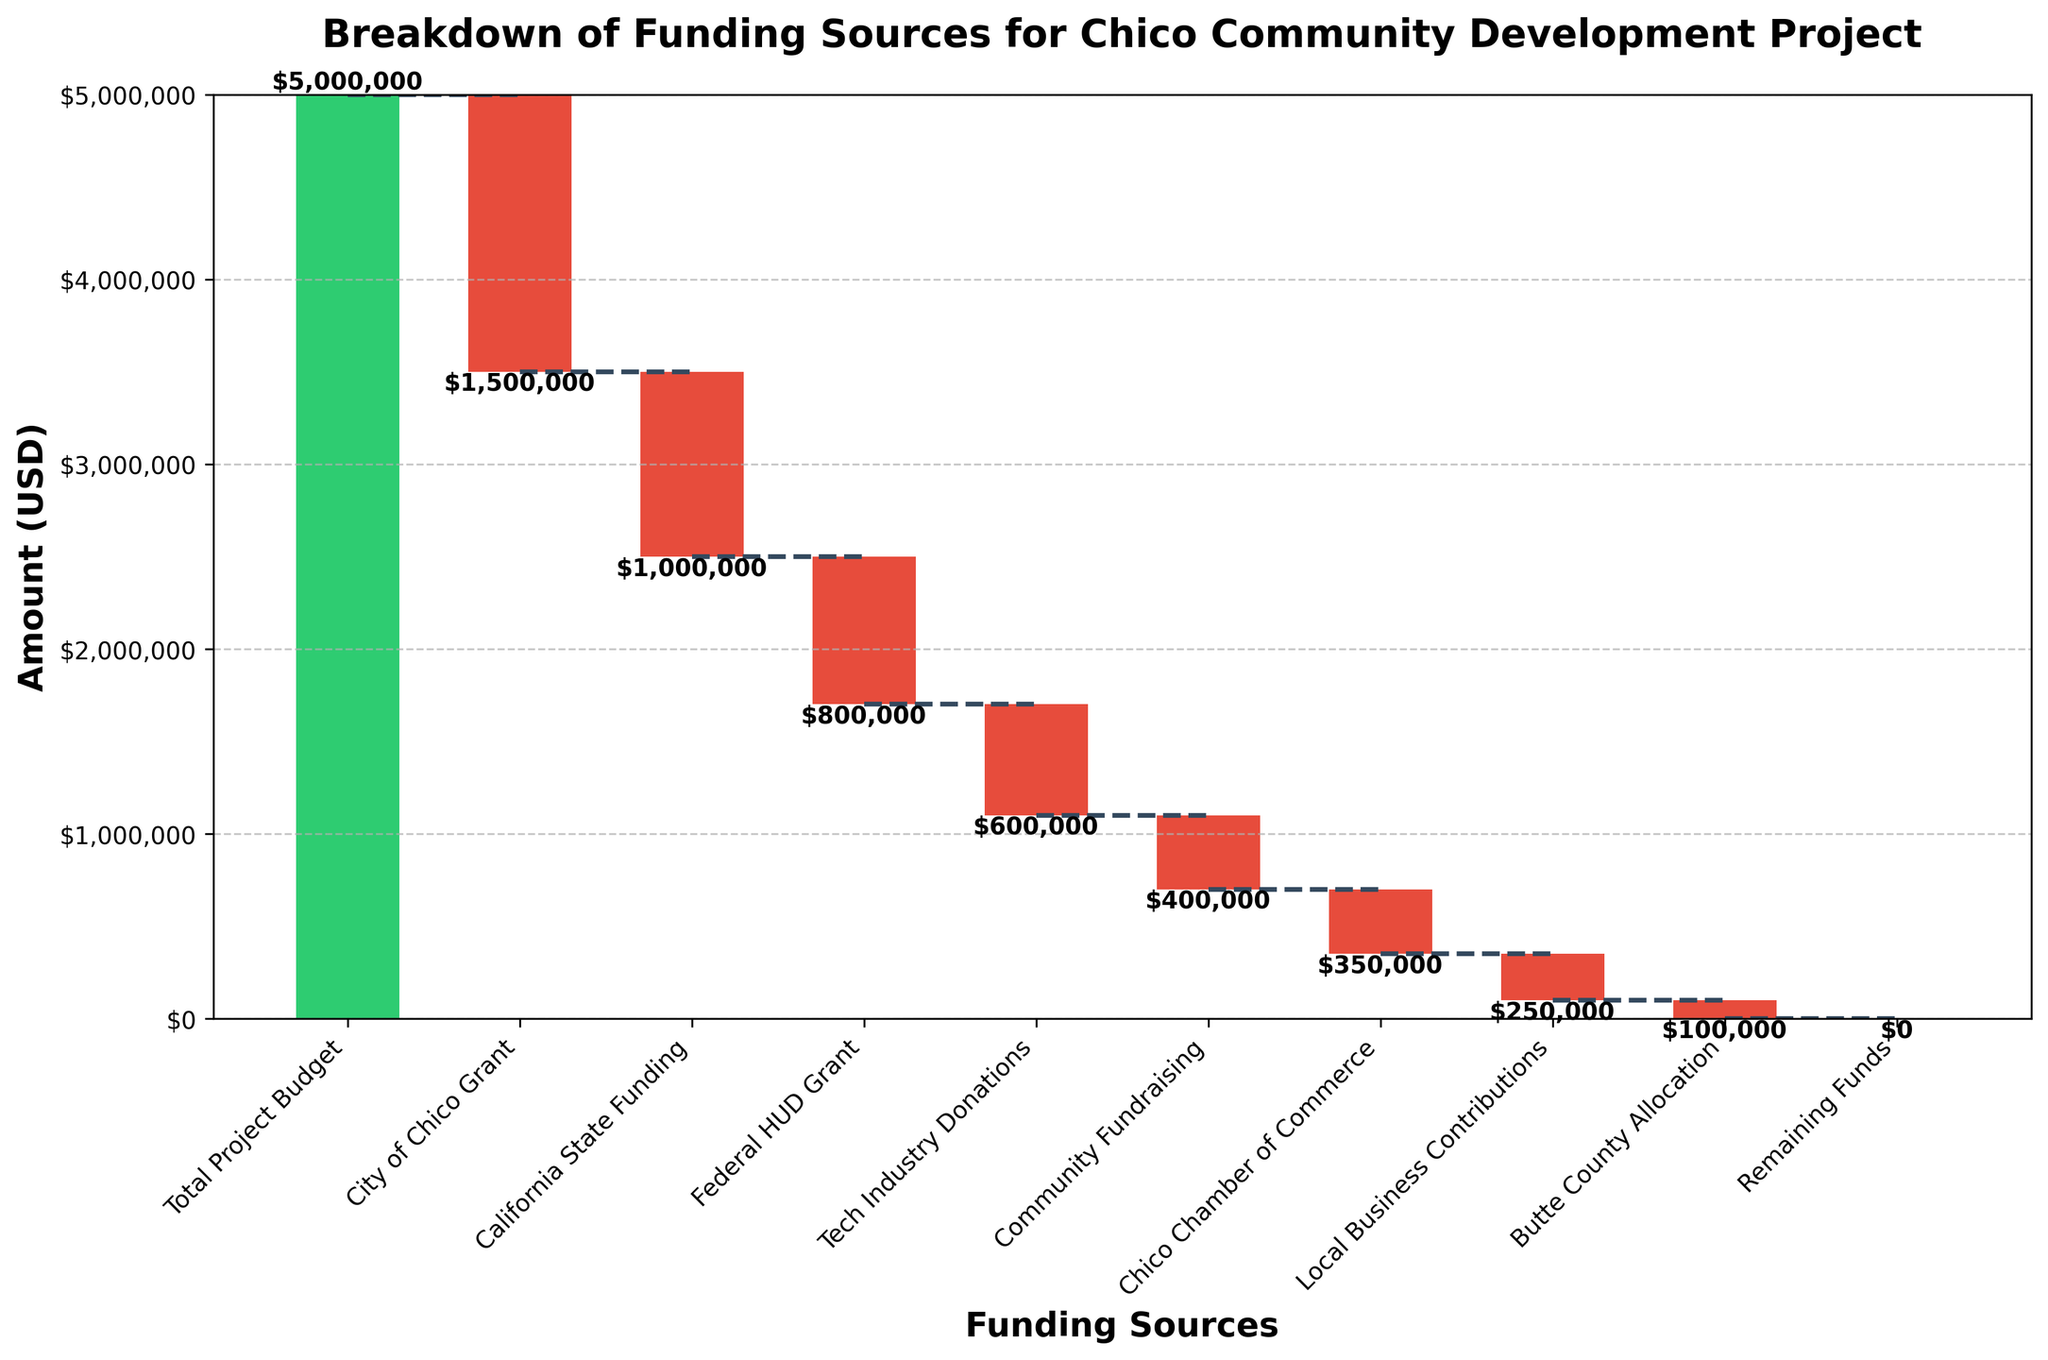Which funding source provided the largest amount of money? The largest amount is indicated by the highest negative value (deepest bar) on the chart. The City of Chico Grant contributed -$1,500,000, which is the largest.
Answer: City of Chico Grant How many different funding sources are listed in the waterfall chart? Counting all unique categories excluding the total project budget and remaining funds, there are 8 unique funding sources.
Answer: 8 Which funding source contributed the least amount of money? The smallest negative value (shallowest bar) represents the smallest contribution, which is Butte County Allocation with -$100,000.
Answer: Butte County Allocation What is the total contribution from the tech industry and community fundraising combined? Summing the contributions from Tech Industry Donations (-$600,000) and Community Fundraising (-$400,000) yields -$1,000,000.
Answer: $1,000,000 By how much did the City of Chico Grant exceed the California State Funding? The difference between the City of Chico Grant (-$1,500,000) and California State Funding (-$1,000,000) is $1,500,000 - $1,000,000 = $500,000.
Answer: $500,000 How much of the total project budget was covered by external funding sources (sum of all negative values)? Adding up all the contributions (negatives) together: -$1,500,000 (City) + -$1,000,000 (State) + -$800,000 (Federal) + -$600,000 (Tech) + -$400,000 (Fundraising) + -$350,000 (Chamber) + -$250,000 (Local Biz) + -$100,000 (County) gives -$5,000,000.
Answer: $5,000,000 Which funding sources’ contributions exceeded half a million dollars? The sources exceeding -$500,000 are City of Chico Grant (-$1,500,000), California State Funding (-$1,000,000), Federal HUD Grant (-$800,000), and Tech Industry Donations (-$600,000).
Answer: Four (City of Chico Grant, California State Funding, Federal HUD Grant, Tech Industry Donations) If the contributions from Chico Chamber of Commerce and Local Business Contributions were combined, how would that total compare to Tech Industry Donations alone? Combined amount of Chico Chamber of Commerce (-$350,000) and Local Business Contributions (-$250,000) is -$350,000 + -$250,000 = -$600,000, which equals the Tech Industry Donations (-$600,000).
Answer: Equal to Tech Industry Donations What is the overall title of the waterfall chart? The title is displayed at the top of the chart and reads "Breakdown of Funding Sources for Chico Community Development Project".
Answer: Breakdown of Funding Sources for Chico Community Development Project 